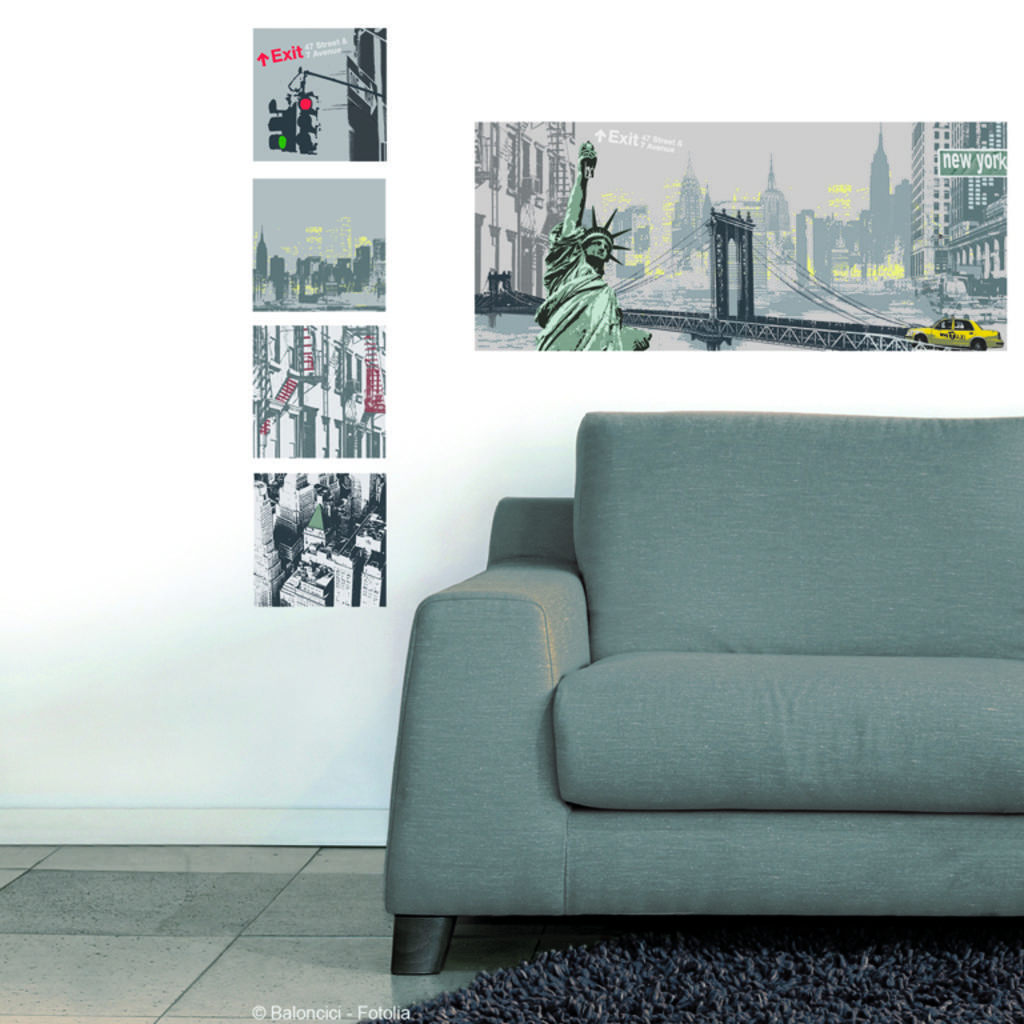In one or two sentences, can you explain what this image depicts? As we can see in the image there is a white color wallpapers and a sofa. 